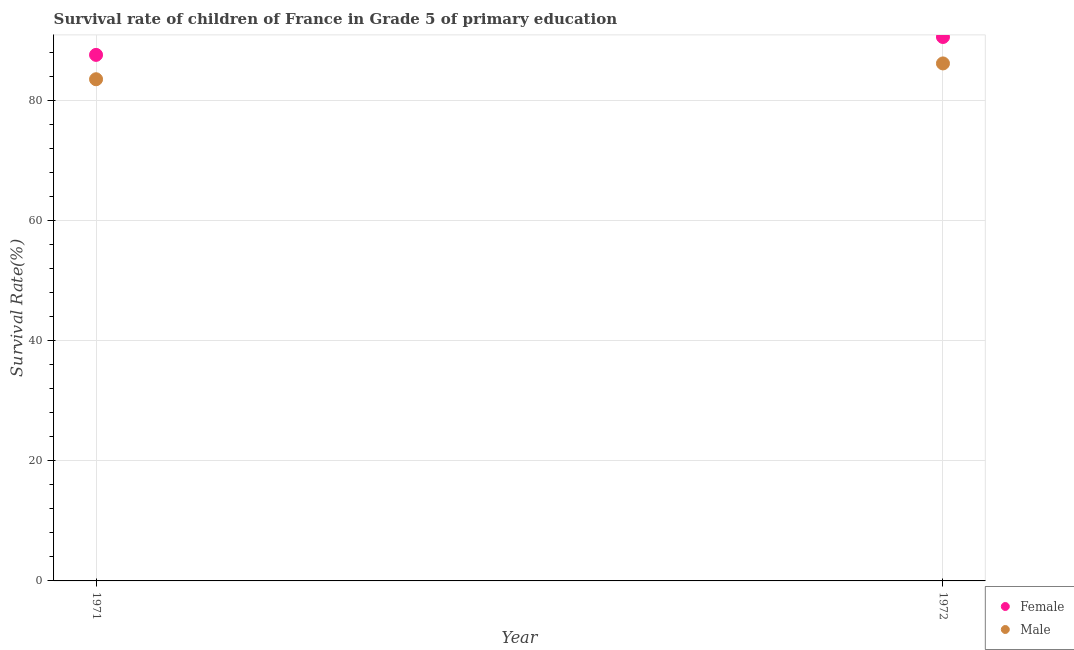How many different coloured dotlines are there?
Offer a very short reply. 2. Is the number of dotlines equal to the number of legend labels?
Provide a succinct answer. Yes. What is the survival rate of male students in primary education in 1971?
Your response must be concise. 83.52. Across all years, what is the maximum survival rate of male students in primary education?
Offer a terse response. 86.16. Across all years, what is the minimum survival rate of female students in primary education?
Offer a terse response. 87.58. In which year was the survival rate of male students in primary education minimum?
Your response must be concise. 1971. What is the total survival rate of female students in primary education in the graph?
Give a very brief answer. 178.14. What is the difference between the survival rate of male students in primary education in 1971 and that in 1972?
Your answer should be very brief. -2.63. What is the difference between the survival rate of male students in primary education in 1972 and the survival rate of female students in primary education in 1971?
Offer a very short reply. -1.42. What is the average survival rate of male students in primary education per year?
Your answer should be compact. 84.84. In the year 1972, what is the difference between the survival rate of female students in primary education and survival rate of male students in primary education?
Provide a succinct answer. 4.4. In how many years, is the survival rate of female students in primary education greater than 24 %?
Provide a short and direct response. 2. What is the ratio of the survival rate of female students in primary education in 1971 to that in 1972?
Provide a succinct answer. 0.97. In how many years, is the survival rate of female students in primary education greater than the average survival rate of female students in primary education taken over all years?
Ensure brevity in your answer.  1. Is the survival rate of female students in primary education strictly less than the survival rate of male students in primary education over the years?
Provide a succinct answer. No. How many dotlines are there?
Keep it short and to the point. 2. What is the difference between two consecutive major ticks on the Y-axis?
Give a very brief answer. 20. Are the values on the major ticks of Y-axis written in scientific E-notation?
Your answer should be compact. No. Does the graph contain any zero values?
Keep it short and to the point. No. How many legend labels are there?
Offer a terse response. 2. What is the title of the graph?
Provide a short and direct response. Survival rate of children of France in Grade 5 of primary education. Does "Savings" appear as one of the legend labels in the graph?
Make the answer very short. No. What is the label or title of the X-axis?
Offer a very short reply. Year. What is the label or title of the Y-axis?
Your answer should be very brief. Survival Rate(%). What is the Survival Rate(%) of Female in 1971?
Provide a short and direct response. 87.58. What is the Survival Rate(%) of Male in 1971?
Offer a terse response. 83.52. What is the Survival Rate(%) of Female in 1972?
Give a very brief answer. 90.56. What is the Survival Rate(%) in Male in 1972?
Offer a very short reply. 86.16. Across all years, what is the maximum Survival Rate(%) of Female?
Your response must be concise. 90.56. Across all years, what is the maximum Survival Rate(%) in Male?
Provide a succinct answer. 86.16. Across all years, what is the minimum Survival Rate(%) of Female?
Ensure brevity in your answer.  87.58. Across all years, what is the minimum Survival Rate(%) of Male?
Your answer should be compact. 83.52. What is the total Survival Rate(%) in Female in the graph?
Offer a very short reply. 178.14. What is the total Survival Rate(%) of Male in the graph?
Give a very brief answer. 169.68. What is the difference between the Survival Rate(%) of Female in 1971 and that in 1972?
Your answer should be very brief. -2.98. What is the difference between the Survival Rate(%) in Male in 1971 and that in 1972?
Make the answer very short. -2.63. What is the difference between the Survival Rate(%) in Female in 1971 and the Survival Rate(%) in Male in 1972?
Give a very brief answer. 1.42. What is the average Survival Rate(%) of Female per year?
Your answer should be very brief. 89.07. What is the average Survival Rate(%) in Male per year?
Keep it short and to the point. 84.84. In the year 1971, what is the difference between the Survival Rate(%) in Female and Survival Rate(%) in Male?
Offer a terse response. 4.06. In the year 1972, what is the difference between the Survival Rate(%) of Female and Survival Rate(%) of Male?
Your response must be concise. 4.4. What is the ratio of the Survival Rate(%) of Female in 1971 to that in 1972?
Keep it short and to the point. 0.97. What is the ratio of the Survival Rate(%) in Male in 1971 to that in 1972?
Ensure brevity in your answer.  0.97. What is the difference between the highest and the second highest Survival Rate(%) of Female?
Your response must be concise. 2.98. What is the difference between the highest and the second highest Survival Rate(%) in Male?
Ensure brevity in your answer.  2.63. What is the difference between the highest and the lowest Survival Rate(%) of Female?
Provide a short and direct response. 2.98. What is the difference between the highest and the lowest Survival Rate(%) in Male?
Provide a succinct answer. 2.63. 